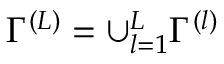<formula> <loc_0><loc_0><loc_500><loc_500>\Gamma ^ { ( L ) } = \cup _ { l = 1 } ^ { L } \Gamma ^ { ( l ) }</formula> 